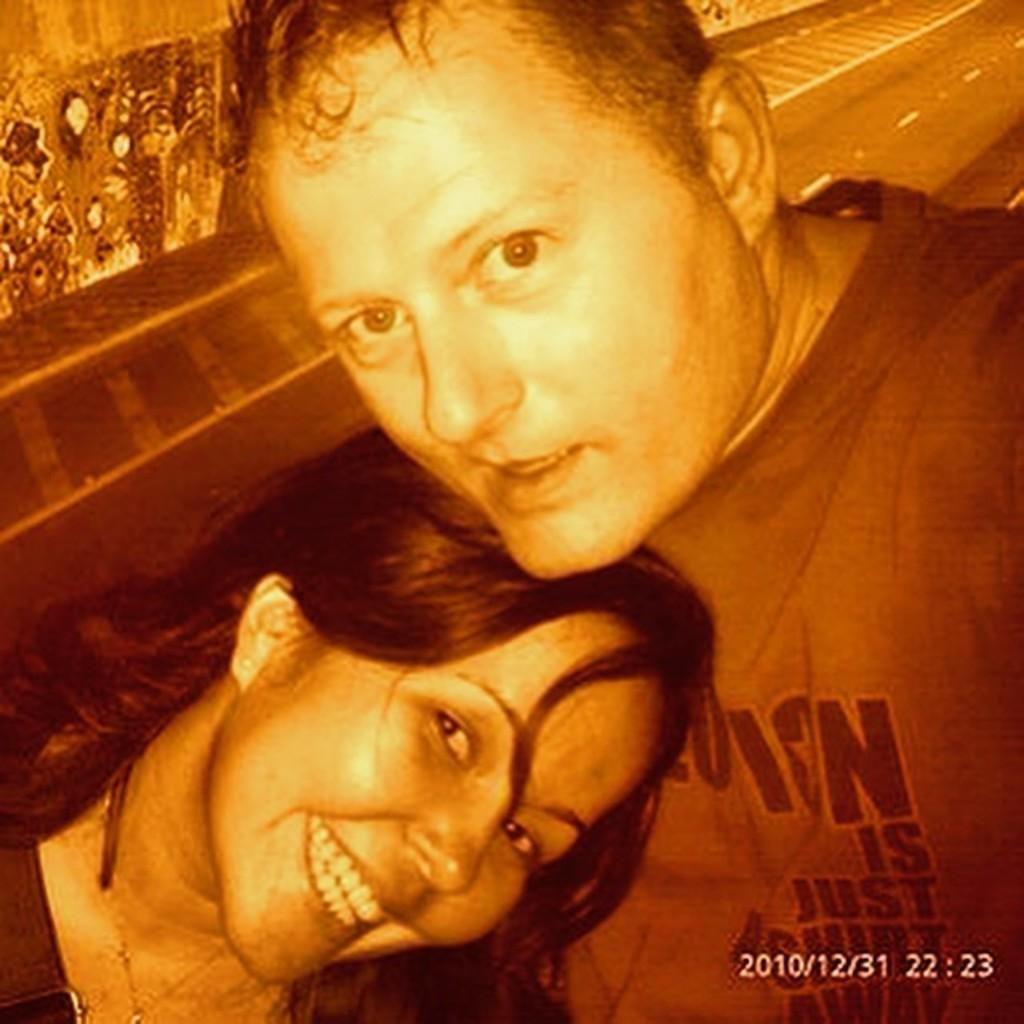Who or what can be seen in the image? There are persons in the image. What are the persons doing in the image? The persons are smiling. Where are the persons located in the image? The persons are in the front of the image. What type of cannon is being used by the porter in the image? There is no porter or cannon present in the image. 